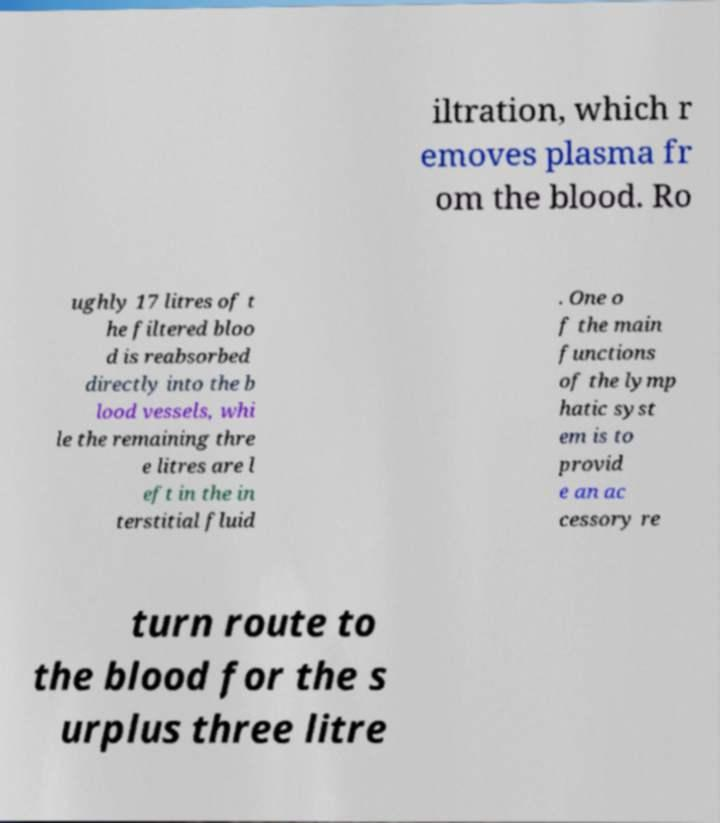Can you accurately transcribe the text from the provided image for me? iltration, which r emoves plasma fr om the blood. Ro ughly 17 litres of t he filtered bloo d is reabsorbed directly into the b lood vessels, whi le the remaining thre e litres are l eft in the in terstitial fluid . One o f the main functions of the lymp hatic syst em is to provid e an ac cessory re turn route to the blood for the s urplus three litre 